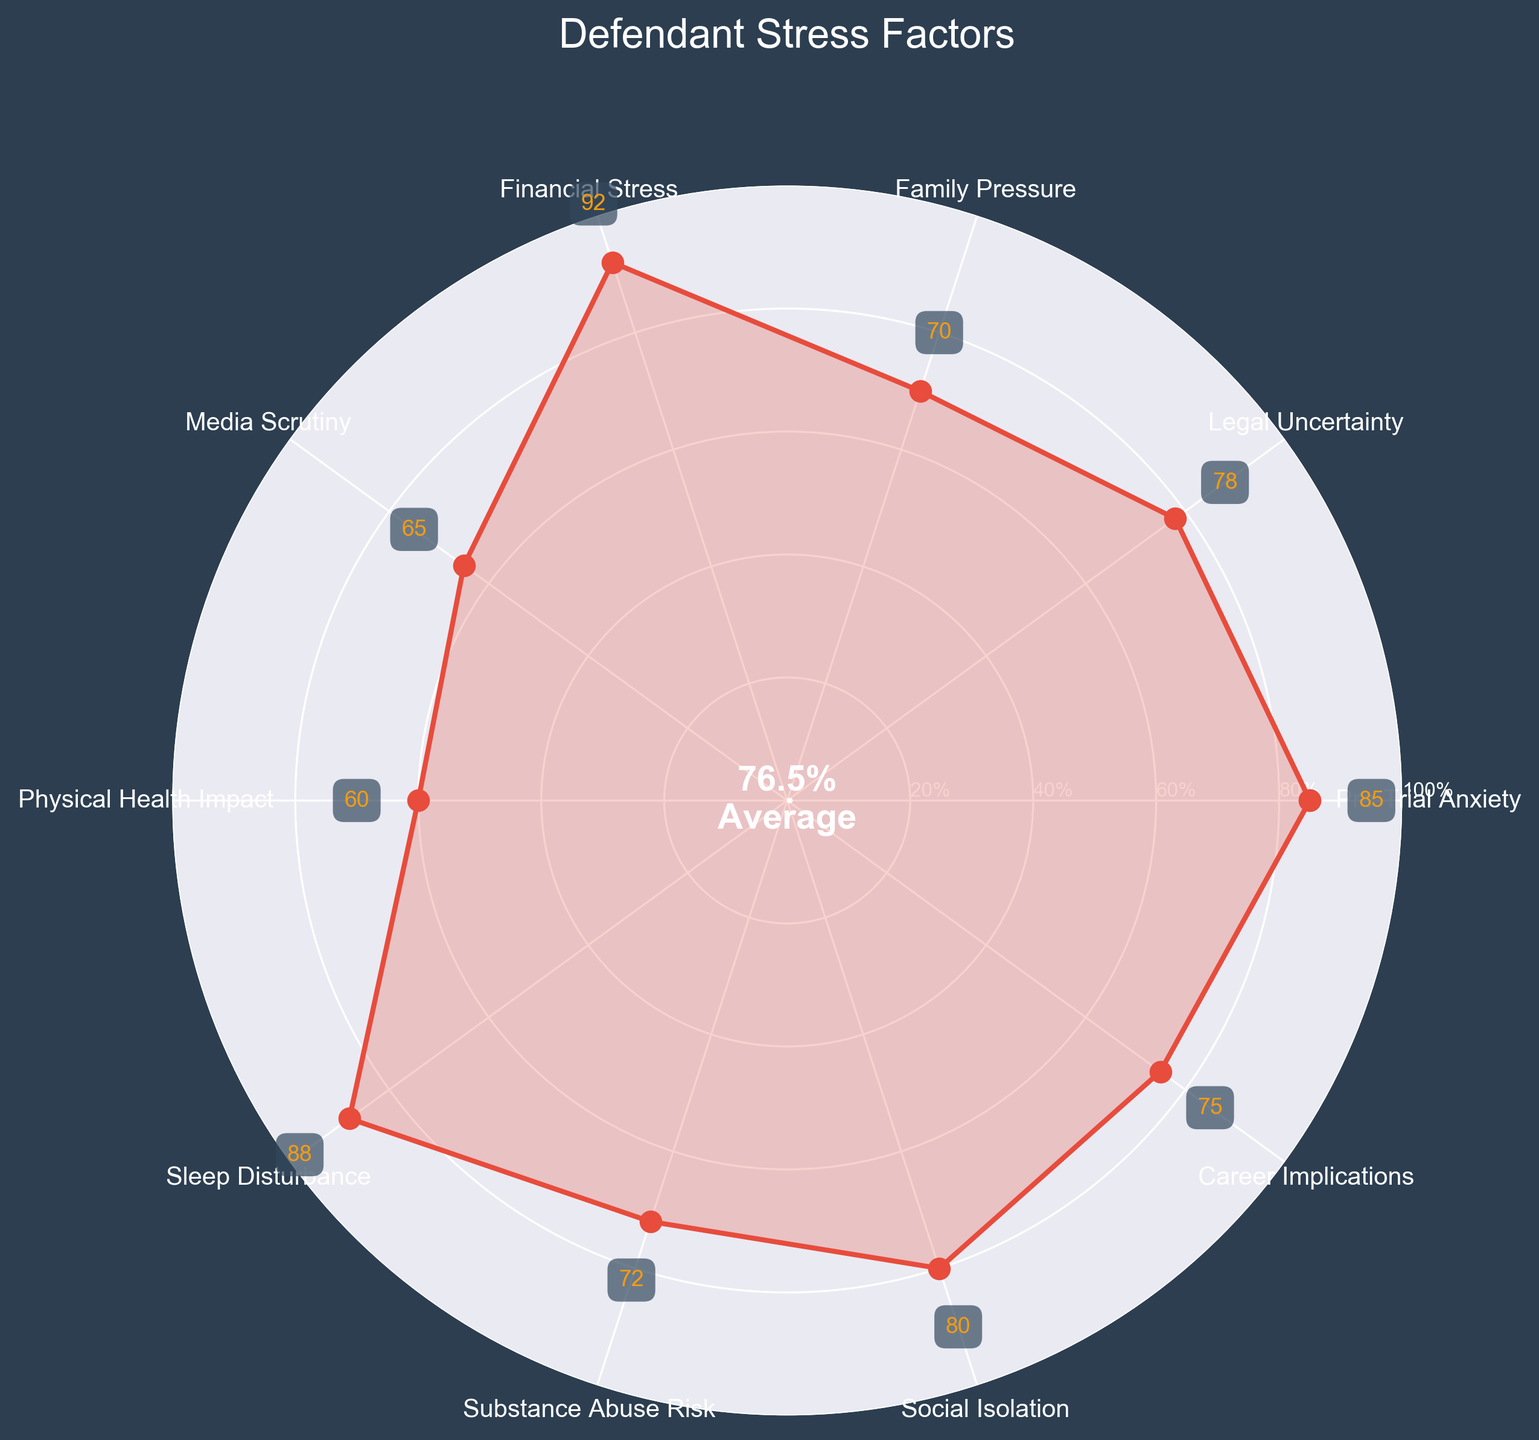What is the title of the plot? The title is usually located at the top of the figure. In this case, the figure title is "Defendant Stress Factors," which gives a clear indication that the plot is about the stress levels of defendants before trial.
Answer: Defendant Stress Factors Which stress factor has the highest value? By looking at the data points and their respective annotations on the plot, we can determine which one has the highest value. The highest value in the provided data is "Financial Stress" with a value of 92.
Answer: Financial Stress How many stress factors are displayed in the plot? Each marker around the polar plot represents a different stress factor. By counting these markers, we determine that there are 10 categories represented in total.
Answer: 10 What is the average stress level of the factors shown? The average value can be found by summing all the individual values and then dividing by the number of categories. Sum of values (85+78+70+92+65+60+88+72+80+75) = 765; divide this by 10 (the number of categories) to get the average. 765 / 10 = 76.5.
Answer: 76.5% Which stress factor corresponds to the innermost circle in the plot? The innermost circle typically corresponds to the lowest value, which, in this case, is "Physical Health Impact" with a value of 60.
Answer: Physical Health Impact How does "Sleep Disturbance" compare to "Media Scrutiny"? By comparing the values for these two categories, we see that "Sleep Disturbance" has a value of 88, while "Media Scrutiny" has a value of 65. Hence, Sleep Disturbance is higher.
Answer: Sleep Disturbance is higher What is the difference between the highest and lowest stress factors? The highest stress factor is "Financial Stress" with a value of 92, and the lowest stress factor is "Physical Health Impact" with a value of 60. The difference is 92 - 60 = 32.
Answer: 32 What is the value for "Legal Uncertainty"? You can find this by looking at the annotation next to the corresponding marker for "Legal Uncertainty." The value is 78.
Answer: 78 Which stress factors have a value greater than or equal to 80? By inspecting the annotations, the stress factors with values ≥ 80 are "Pre-Trial Anxiety" (85), "Sleep Disturbance" (88), and "Social Isolation" (80).
Answer: Pre-Trial Anxiety, Sleep Disturbance, Social Isolation What is the value displayed in the center of the plot, and what does it represent? The center of the plot usually shows the average value of all the stress factors combined. In this polar plot, it displays 76.5% and represents the average stress level of all the categories.
Answer: 76.5% 